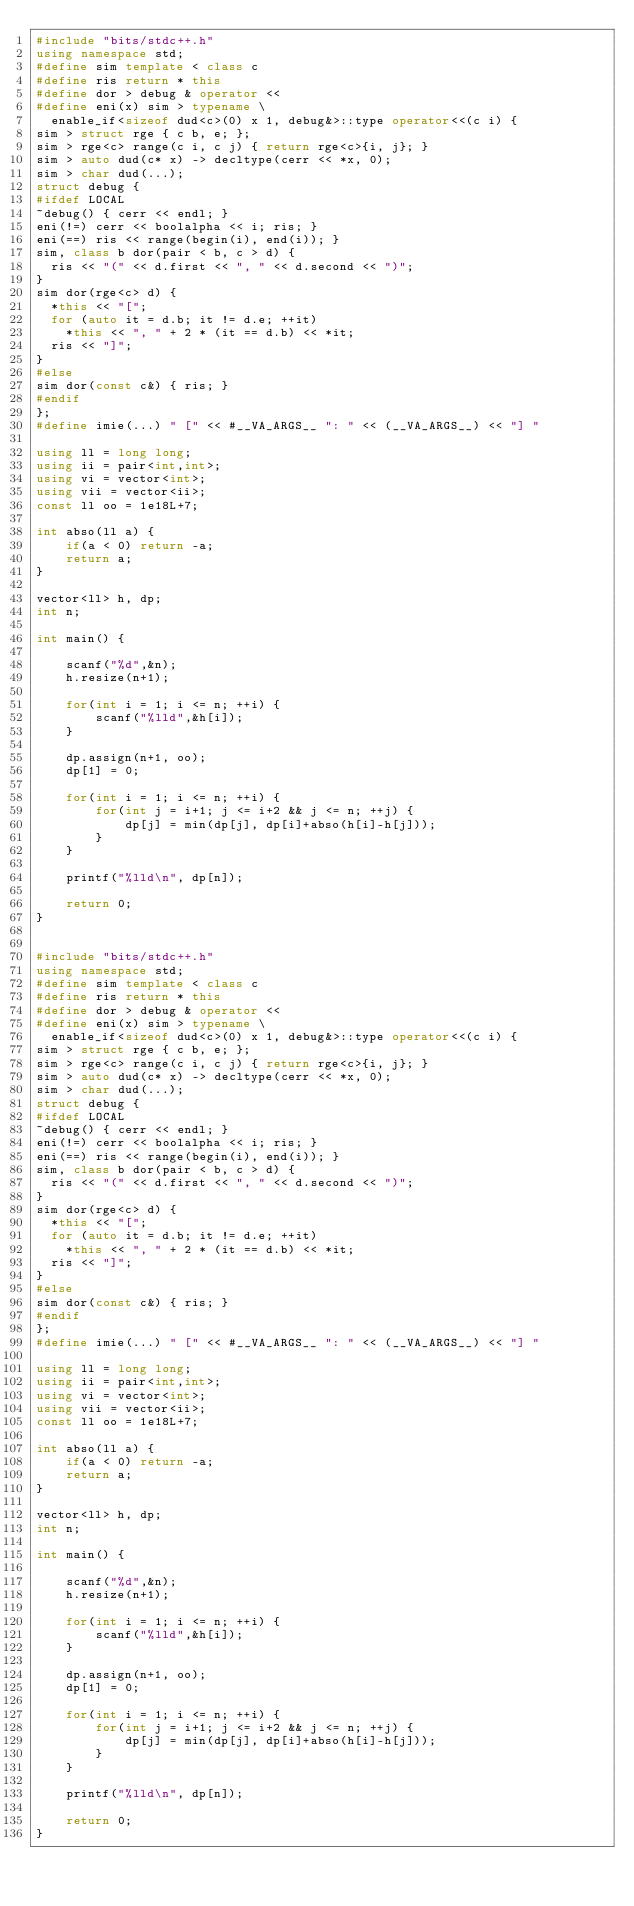Convert code to text. <code><loc_0><loc_0><loc_500><loc_500><_C++_>#include "bits/stdc++.h"
using namespace std;
#define sim template < class c
#define ris return * this
#define dor > debug & operator <<
#define eni(x) sim > typename \
  enable_if<sizeof dud<c>(0) x 1, debug&>::type operator<<(c i) {
sim > struct rge { c b, e; };
sim > rge<c> range(c i, c j) { return rge<c>{i, j}; }
sim > auto dud(c* x) -> decltype(cerr << *x, 0);
sim > char dud(...);
struct debug {
#ifdef LOCAL
~debug() { cerr << endl; }
eni(!=) cerr << boolalpha << i; ris; }
eni(==) ris << range(begin(i), end(i)); }
sim, class b dor(pair < b, c > d) {
  ris << "(" << d.first << ", " << d.second << ")";
}
sim dor(rge<c> d) {
  *this << "[";
  for (auto it = d.b; it != d.e; ++it)
    *this << ", " + 2 * (it == d.b) << *it;
  ris << "]";
}
#else
sim dor(const c&) { ris; }
#endif
};
#define imie(...) " [" << #__VA_ARGS__ ": " << (__VA_ARGS__) << "] "

using ll = long long;
using ii = pair<int,int>;
using vi = vector<int>;
using vii = vector<ii>;
const ll oo = 1e18L+7;

int abso(ll a) {
    if(a < 0) return -a;
    return a;
}

vector<ll> h, dp;
int n;

int main() {
    
    scanf("%d",&n);
    h.resize(n+1);
    
    for(int i = 1; i <= n; ++i) {
        scanf("%lld",&h[i]);
    }
    
    dp.assign(n+1, oo);
    dp[1] = 0;
    
    for(int i = 1; i <= n; ++i) {
        for(int j = i+1; j <= i+2 && j <= n; ++j) {
            dp[j] = min(dp[j], dp[i]+abso(h[i]-h[j]));
        }
    }

    printf("%lld\n", dp[n]);
    
    return 0;
}


#include "bits/stdc++.h"
using namespace std;
#define sim template < class c
#define ris return * this
#define dor > debug & operator <<
#define eni(x) sim > typename \
  enable_if<sizeof dud<c>(0) x 1, debug&>::type operator<<(c i) {
sim > struct rge { c b, e; };
sim > rge<c> range(c i, c j) { return rge<c>{i, j}; }
sim > auto dud(c* x) -> decltype(cerr << *x, 0);
sim > char dud(...);
struct debug {
#ifdef LOCAL
~debug() { cerr << endl; }
eni(!=) cerr << boolalpha << i; ris; }
eni(==) ris << range(begin(i), end(i)); }
sim, class b dor(pair < b, c > d) {
  ris << "(" << d.first << ", " << d.second << ")";
}
sim dor(rge<c> d) {
  *this << "[";
  for (auto it = d.b; it != d.e; ++it)
    *this << ", " + 2 * (it == d.b) << *it;
  ris << "]";
}
#else
sim dor(const c&) { ris; }
#endif
};
#define imie(...) " [" << #__VA_ARGS__ ": " << (__VA_ARGS__) << "] "

using ll = long long;
using ii = pair<int,int>;
using vi = vector<int>;
using vii = vector<ii>;
const ll oo = 1e18L+7;

int abso(ll a) {
    if(a < 0) return -a;
    return a;
}

vector<ll> h, dp;
int n;

int main() {
    
    scanf("%d",&n);
    h.resize(n+1);
    
    for(int i = 1; i <= n; ++i) {
        scanf("%lld",&h[i]);
    }
    
    dp.assign(n+1, oo);
    dp[1] = 0;
    
    for(int i = 1; i <= n; ++i) {
        for(int j = i+1; j <= i+2 && j <= n; ++j) {
            dp[j] = min(dp[j], dp[i]+abso(h[i]-h[j]));
        }
    }

    printf("%lld\n", dp[n]);
    
    return 0;
}


</code> 